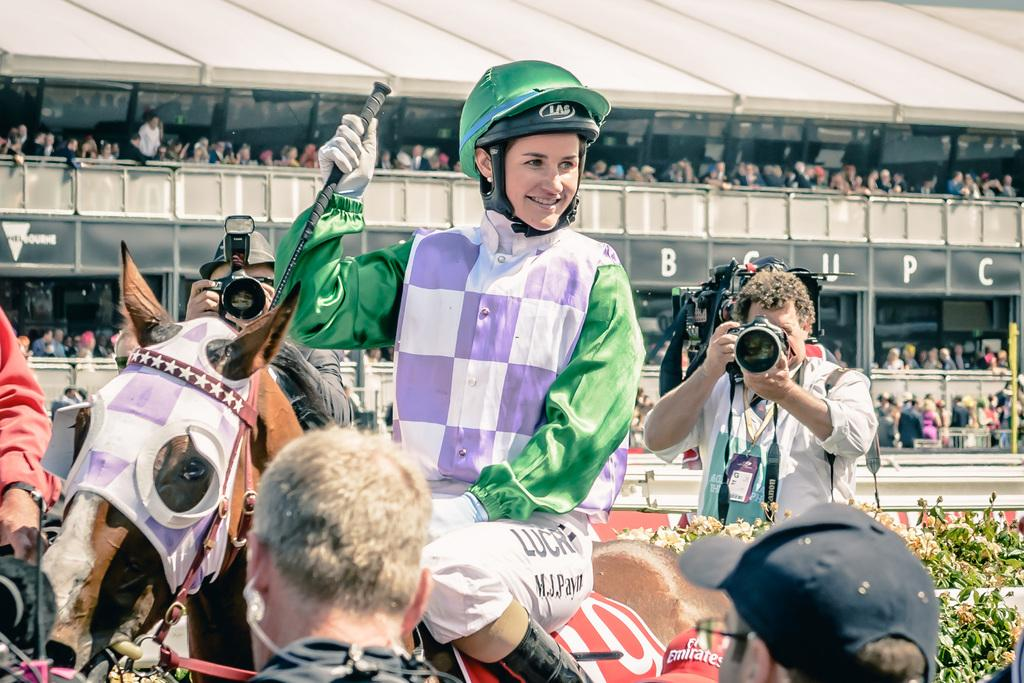How many people are present in the image? There are many people in the image. What objects are visible in the image that are used for capturing images? There are cameras in the image. What type of living organisms can be seen in the image besides people? There are plants and a horse in the image. What architectural feature is visible in the background of the image? There is a fence in the background of the image. What else can be seen in the background of the image? There is written text in the background of the image. What type of cat is responsible for the horse's digestion in the image? There is no cat or mention of digestion in the image; it features people, cameras, plants, a horse, a fence, and written text. 